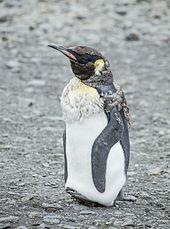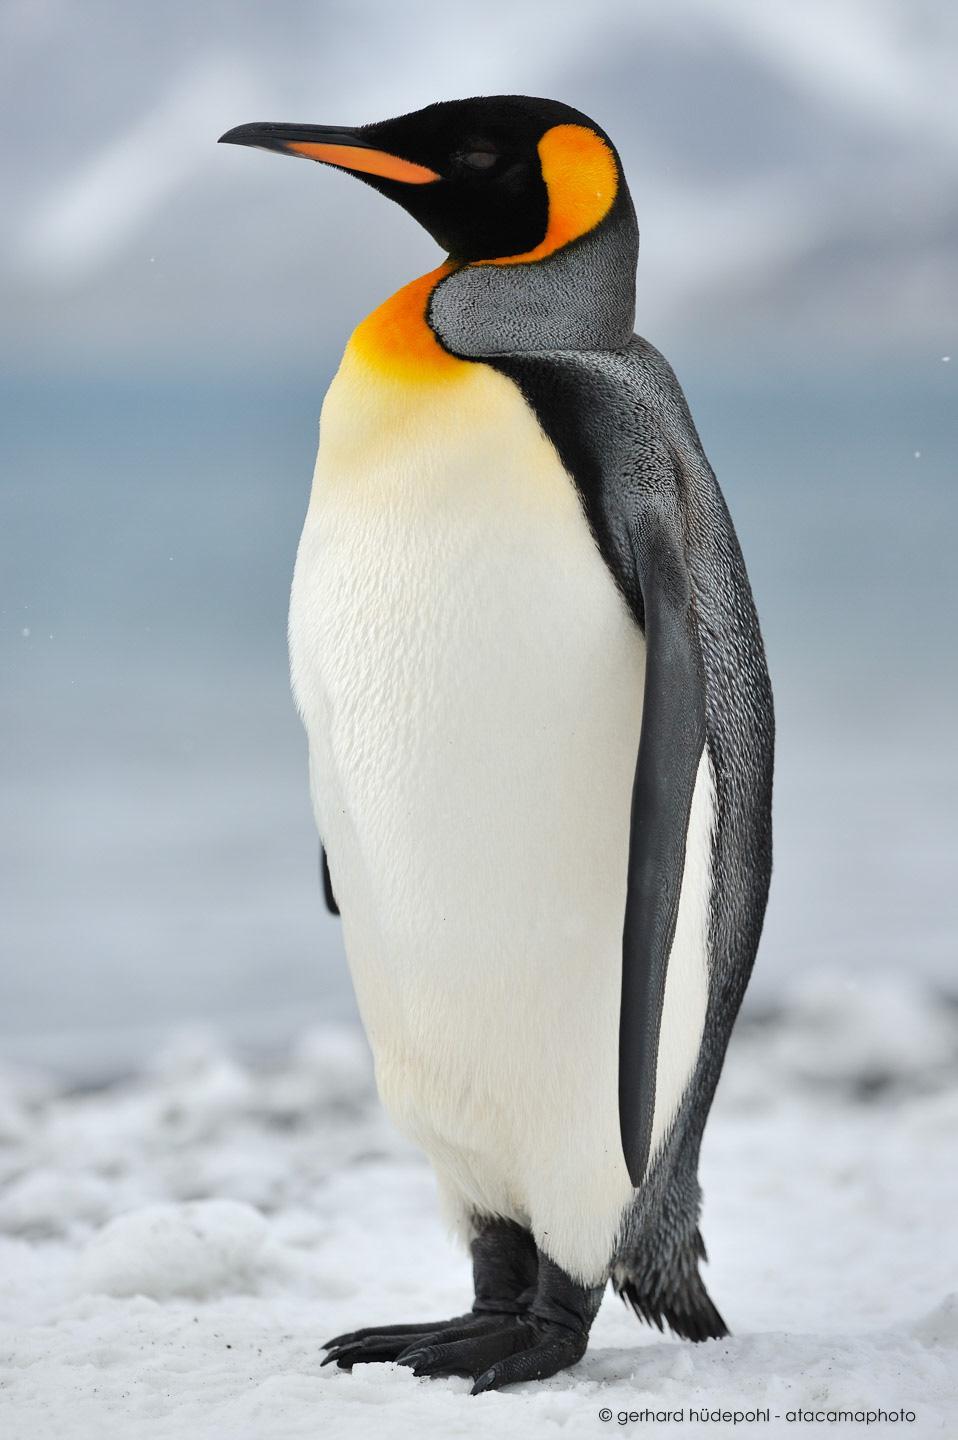The first image is the image on the left, the second image is the image on the right. Considering the images on both sides, is "There are no more than three penguins standing on the ground." valid? Answer yes or no. Yes. The first image is the image on the left, the second image is the image on the right. Evaluate the accuracy of this statement regarding the images: "multiple peguins white bellies are facing the camera". Is it true? Answer yes or no. No. The first image is the image on the left, the second image is the image on the right. For the images shown, is this caption "Atleast one picture with only one penguin." true? Answer yes or no. Yes. The first image is the image on the left, the second image is the image on the right. Considering the images on both sides, is "There are four penguins in total." valid? Answer yes or no. No. The first image is the image on the left, the second image is the image on the right. Assess this claim about the two images: "There are two penguins". Correct or not? Answer yes or no. Yes. The first image is the image on the left, the second image is the image on the right. Assess this claim about the two images: "There are two penguins in the image pair.". Correct or not? Answer yes or no. Yes. The first image is the image on the left, the second image is the image on the right. Analyze the images presented: Is the assertion "One of the images includes a single penguin facing to the left." valid? Answer yes or no. Yes. The first image is the image on the left, the second image is the image on the right. Considering the images on both sides, is "Each image contains a single penguin, and the penguins share similar body poses." valid? Answer yes or no. Yes. The first image is the image on the left, the second image is the image on the right. For the images displayed, is the sentence "An image shows a horizontal row of upright penguins, all facing right." factually correct? Answer yes or no. No. The first image is the image on the left, the second image is the image on the right. Assess this claim about the two images: "Each image shows exactly two penguins posed close together.". Correct or not? Answer yes or no. No. 